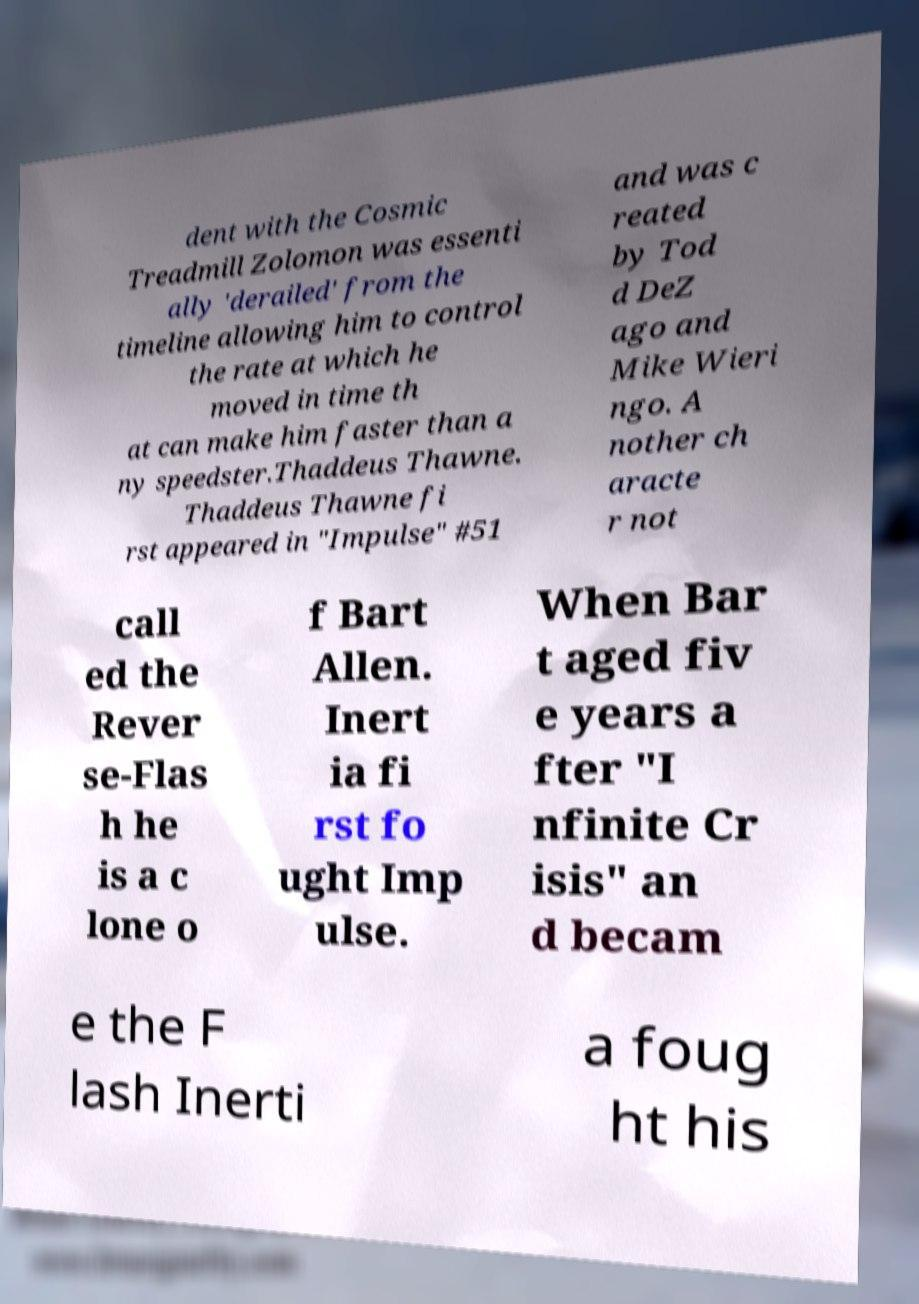Please read and relay the text visible in this image. What does it say? dent with the Cosmic Treadmill Zolomon was essenti ally 'derailed' from the timeline allowing him to control the rate at which he moved in time th at can make him faster than a ny speedster.Thaddeus Thawne. Thaddeus Thawne fi rst appeared in "Impulse" #51 and was c reated by Tod d DeZ ago and Mike Wieri ngo. A nother ch aracte r not call ed the Rever se-Flas h he is a c lone o f Bart Allen. Inert ia fi rst fo ught Imp ulse. When Bar t aged fiv e years a fter "I nfinite Cr isis" an d becam e the F lash Inerti a foug ht his 